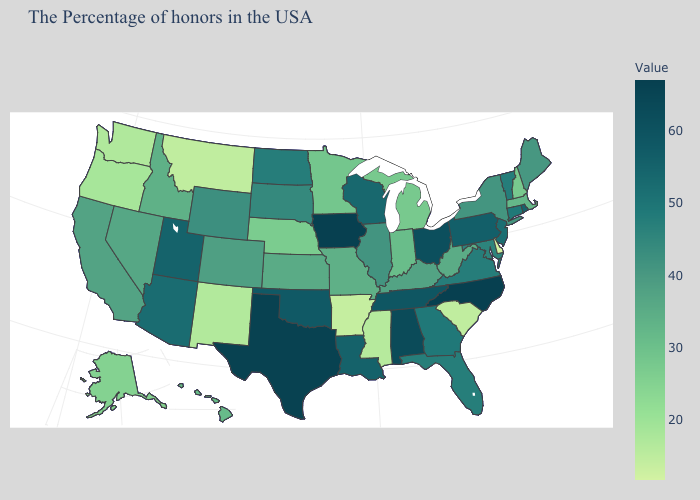Does Utah have the highest value in the West?
Give a very brief answer. Yes. Does New York have a lower value than Iowa?
Concise answer only. Yes. Among the states that border New Mexico , which have the lowest value?
Keep it brief. Colorado. Is the legend a continuous bar?
Keep it brief. Yes. Which states have the lowest value in the USA?
Keep it brief. Delaware. 